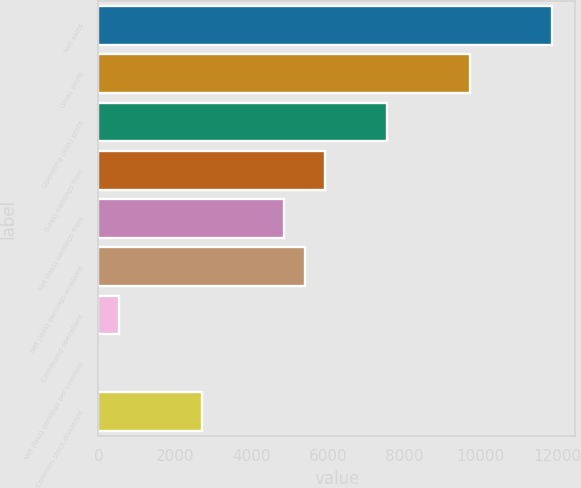Convert chart to OTSL. <chart><loc_0><loc_0><loc_500><loc_500><bar_chart><fcel>Net sales<fcel>Gross profit<fcel>Operating (loss) profit<fcel>(Loss) earnings from<fcel>Net (loss) earnings from<fcel>Net (loss) earnings available<fcel>Continuing operations<fcel>Net (loss) earnings per common<fcel>Common stock dividends<nl><fcel>11877<fcel>9717.84<fcel>7558.64<fcel>5939.24<fcel>4859.64<fcel>5399.44<fcel>541.24<fcel>1.44<fcel>2700.44<nl></chart> 